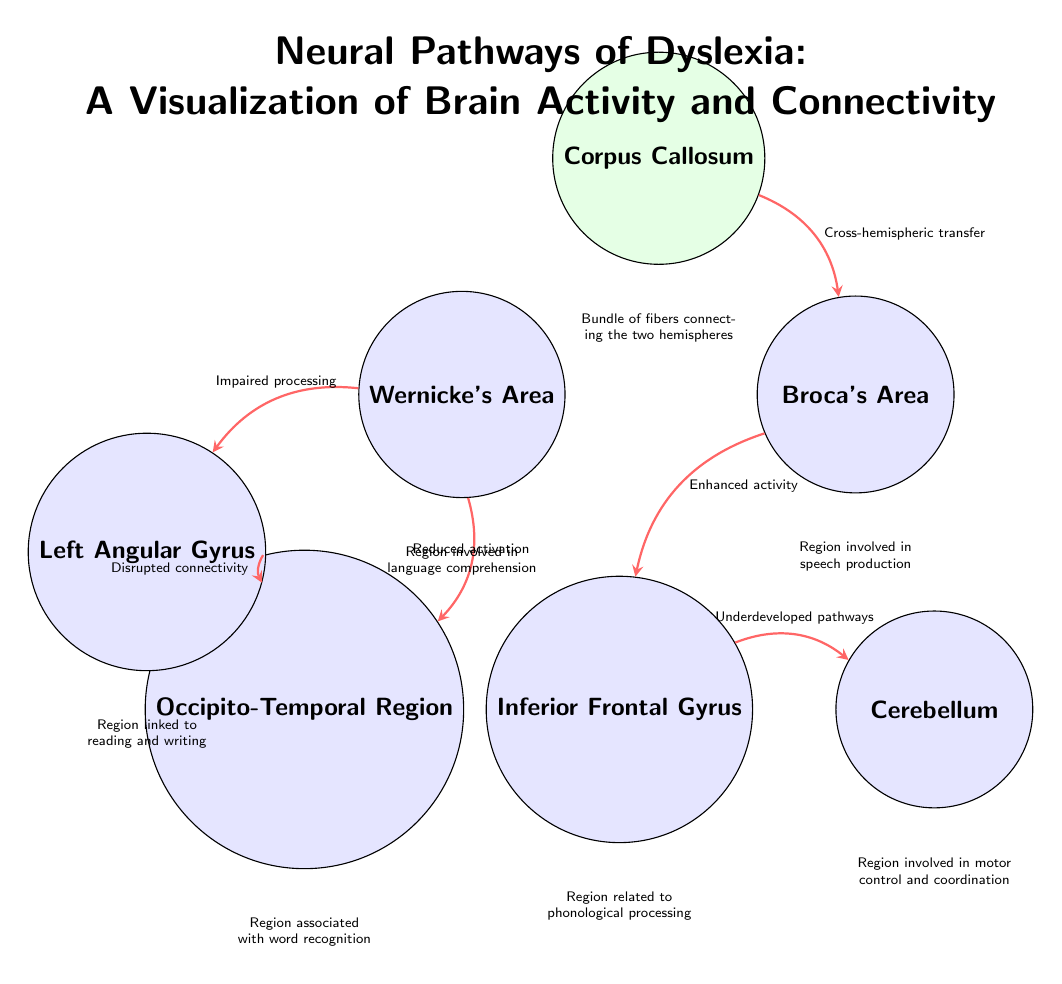What is the color of the Corpus Callosum node? The diagram shows the Corpus Callosum node filled with green!10, which indicates a light green color.
Answer: green How many brain regions are represented in the diagram? The diagram contains six brain regions represented by different nodes: Wernicke's Area, Broca's Area, Occipito-Temporal Region, Inferior Frontal Gyrus, Left Angular Gyrus, and Cerebellum.
Answer: six What type of relationship is depicted between Wernicke's Area and the Occipito-Temporal Region? A connection from Wernicke's Area to the Occipito-Temporal Region is indicated as "Reduced activation," indicating a negative or impaired relationship.
Answer: Reduced activation Which region is connected to the Inferior Frontal Gyrus with "Underdeveloped pathways"? The diagram shows that the Inferior Frontal Gyrus is connected to the Cerebellum with the label "Underdeveloped pathways."
Answer: Cerebellum What is the main role of the Left Angular Gyrus? The Left Angular Gyrus is identified as the region linked to reading and writing, which highlights its specific involvement in literacy processes.
Answer: reading and writing Explain the significance of the connection labeled "Cross-hemispheric transfer." The connection labeled "Cross-hemispheric transfer" from the Corpus Callosum to Broca's Area indicates the importance of this bundle of fibers in facilitating communication between the left and right hemispheres, especially in speech production.
Answer: communication between hemispheres Which brain region is associated with word recognition? The Occipito-Temporal Region is explicitly described in the diagram as being associated with word recognition, indicating its function in visual word form processing.
Answer: Occipito-Temporal Region What does the arrow between Broca's Area and the Inferior Frontal Gyrus indicate? The arrow between Broca's Area and the Inferior Frontal Gyrus is shown with "Enhanced activity," suggesting a positive connection between speech production and phonological processing capabilities in dyslexia.
Answer: Enhanced activity 